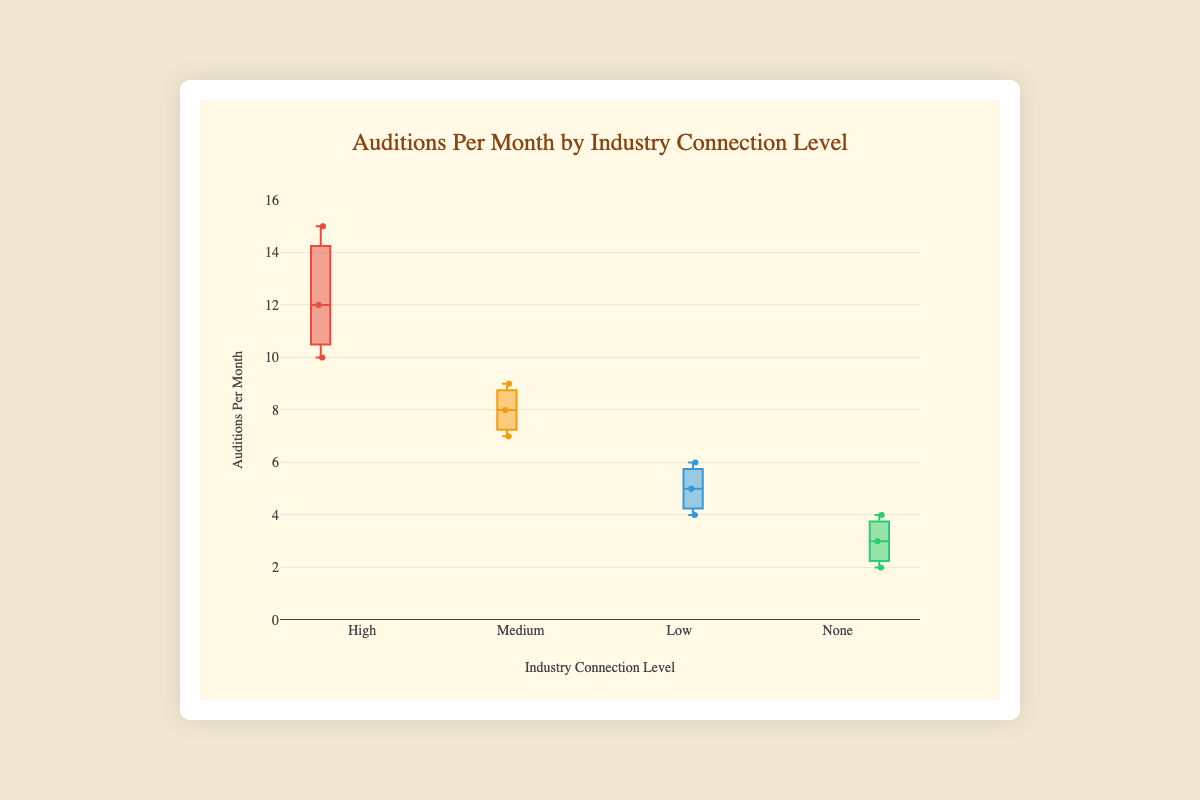What's the title of the figure? The title of the figure is found at the top and usually describes the subject of the plot. Here, it reads "Auditions Per Month by Industry Connection Level".
Answer: Auditions Per Month by Industry Connection Level What is the maximum number of auditions attended per month by actors with a high level of industry connections? By looking at the data points in the "High" box, the highest audition count is visible. This value is 15, attended by Margot Robbie.
Answer: 15 What is the average number of auditions per month for actors with a medium level of industry connections? The three actors with medium-level connections have audition counts of 8, 9, and 7. Add these values (8 + 9 + 7 = 24) and divide by the number of data points (24 / 3 = 8).
Answer: 8 Which connection level has the smallest range of audition counts? The range is calculated as the difference between the maximum and minimum values in each group. Identifying the smallest range involves comparison among High (15-10=5), Medium (9-7=2), Low (6-4=2), and None (4-2=2) levels. Here, Medium, Low, and None all have ranges of 2; thus, they all have the smallest range.
Answer: Medium, Low, None Which connection level has the lowest median number of auditions per month? The median is the middle value when the data points are ordered. For None, the data points are 2, 3, 4, and the median is 3. Compare with other groups' medians: High (12), Medium (8), Low (5). The median for None is 3, which is the lowest.
Answer: None Is the median number of auditions greater for actors with medium connections than those with low connections? Calculate the median for Medium (8, 9, 7; median is 8) and Low (5, 6, 4; median is 5). Compare these two values: 8 > 5.
Answer: Yes How many actors with no industry connections attended auditions more frequently than the least frequent auditioner in the Low category? The least frequent in Low category is 4 (Sadie Sink). Actors in None category auditioning more than 4 times: None of the actors in None attended more frequently than 4.
Answer: 0 Which actor attended the maximum number of auditions per month across all connection levels? By examining each group, Margot Robbie, in the High group, attended the most with 15 auditions per month.
Answer: Margot Robbie What is the interquartile range (IQR) for the High connection level? The IQR is the difference between the third quartile (Q3) and the first quartile (Q1). From figure data: Q1 ~ 10.5, Q3 ~ 14. The IQR = Q3 - Q1 = 14 - 10.5 = 3.5.
Answer: 3.5 How do the median numbers of auditions compare between actors with high and none industry connections? Median for High is around 12, and for None it is 3. The median number of auditions for High is significantly greater than None.
Answer: High is greater 